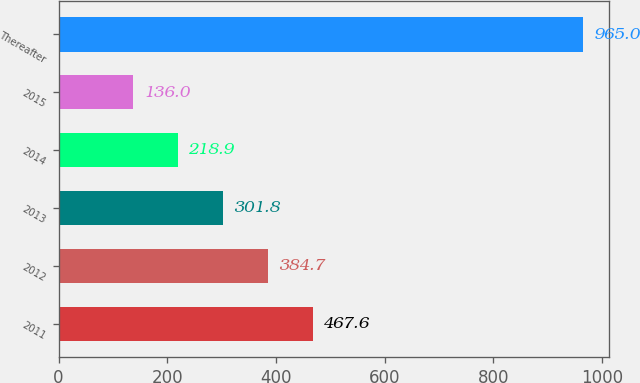<chart> <loc_0><loc_0><loc_500><loc_500><bar_chart><fcel>2011<fcel>2012<fcel>2013<fcel>2014<fcel>2015<fcel>Thereafter<nl><fcel>467.6<fcel>384.7<fcel>301.8<fcel>218.9<fcel>136<fcel>965<nl></chart> 